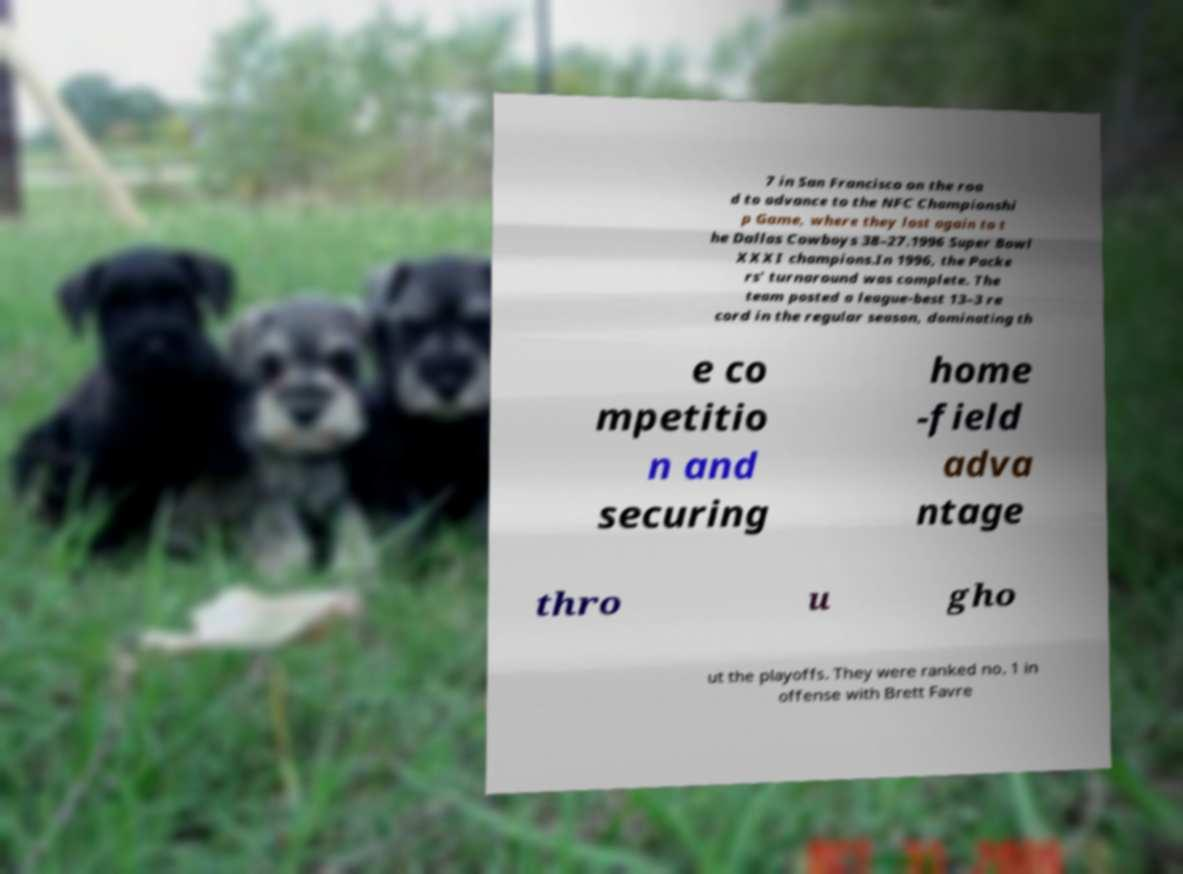There's text embedded in this image that I need extracted. Can you transcribe it verbatim? 7 in San Francisco on the roa d to advance to the NFC Championshi p Game, where they lost again to t he Dallas Cowboys 38–27.1996 Super Bowl XXXI champions.In 1996, the Packe rs' turnaround was complete. The team posted a league-best 13–3 re cord in the regular season, dominating th e co mpetitio n and securing home -field adva ntage thro u gho ut the playoffs. They were ranked no. 1 in offense with Brett Favre 